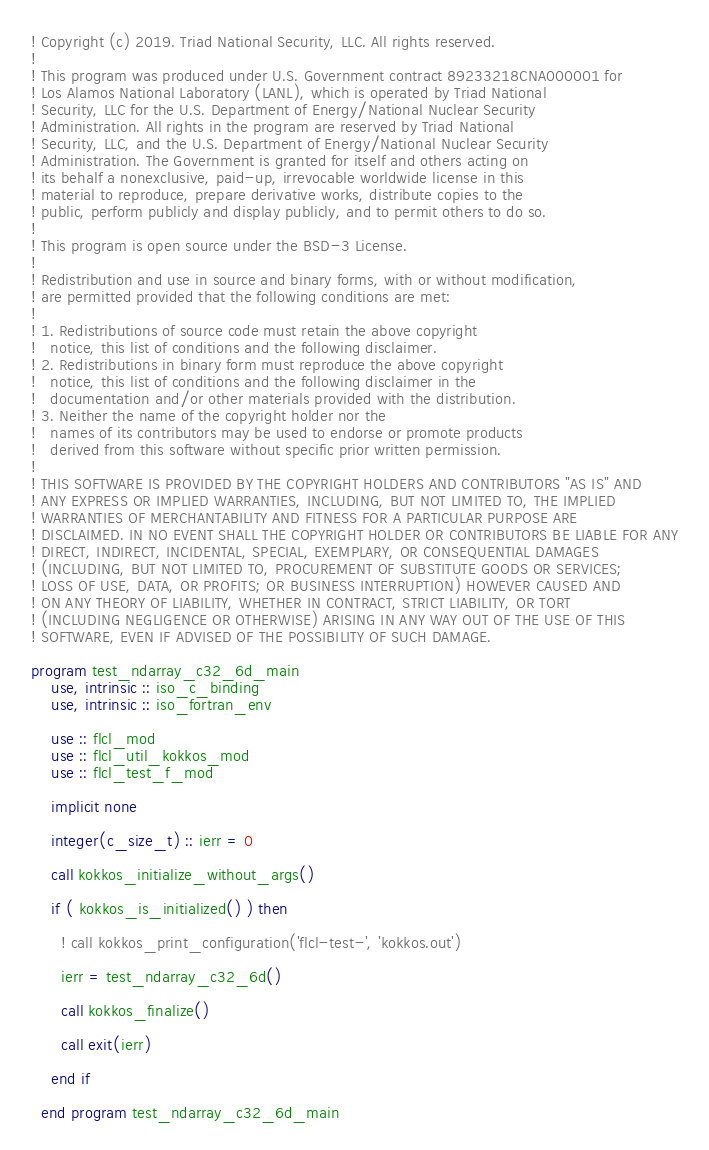Convert code to text. <code><loc_0><loc_0><loc_500><loc_500><_FORTRAN_>! Copyright (c) 2019. Triad National Security, LLC. All rights reserved.
!
! This program was produced under U.S. Government contract 89233218CNA000001 for
! Los Alamos National Laboratory (LANL), which is operated by Triad National
! Security, LLC for the U.S. Department of Energy/National Nuclear Security
! Administration. All rights in the program are reserved by Triad National
! Security, LLC, and the U.S. Department of Energy/National Nuclear Security
! Administration. The Government is granted for itself and others acting on
! its behalf a nonexclusive, paid-up, irrevocable worldwide license in this
! material to reproduce, prepare derivative works, distribute copies to the
! public, perform publicly and display publicly, and to permit others to do so.
!
! This program is open source under the BSD-3 License.
!
! Redistribution and use in source and binary forms, with or without modification,
! are permitted provided that the following conditions are met:
!
! 1. Redistributions of source code must retain the above copyright
!   notice, this list of conditions and the following disclaimer.
! 2. Redistributions in binary form must reproduce the above copyright
!   notice, this list of conditions and the following disclaimer in the
!   documentation and/or other materials provided with the distribution.
! 3. Neither the name of the copyright holder nor the
!   names of its contributors may be used to endorse or promote products
!   derived from this software without specific prior written permission.
!
! THIS SOFTWARE IS PROVIDED BY THE COPYRIGHT HOLDERS AND CONTRIBUTORS "AS IS" AND
! ANY EXPRESS OR IMPLIED WARRANTIES, INCLUDING, BUT NOT LIMITED TO, THE IMPLIED
! WARRANTIES OF MERCHANTABILITY AND FITNESS FOR A PARTICULAR PURPOSE ARE
! DISCLAIMED. IN NO EVENT SHALL THE COPYRIGHT HOLDER OR CONTRIBUTORS BE LIABLE FOR ANY
! DIRECT, INDIRECT, INCIDENTAL, SPECIAL, EXEMPLARY, OR CONSEQUENTIAL DAMAGES
! (INCLUDING, BUT NOT LIMITED TO, PROCUREMENT OF SUBSTITUTE GOODS OR SERVICES;
! LOSS OF USE, DATA, OR PROFITS; OR BUSINESS INTERRUPTION) HOWEVER CAUSED AND
! ON ANY THEORY OF LIABILITY, WHETHER IN CONTRACT, STRICT LIABILITY, OR TORT
! (INCLUDING NEGLIGENCE OR OTHERWISE) ARISING IN ANY WAY OUT OF THE USE OF THIS
! SOFTWARE, EVEN IF ADVISED OF THE POSSIBILITY OF SUCH DAMAGE.

program test_ndarray_c32_6d_main
    use, intrinsic :: iso_c_binding
    use, intrinsic :: iso_fortran_env
  
    use :: flcl_mod
    use :: flcl_util_kokkos_mod
    use :: flcl_test_f_mod
  
    implicit none
  
    integer(c_size_t) :: ierr = 0
  
    call kokkos_initialize_without_args()

    if ( kokkos_is_initialized() ) then
      
      ! call kokkos_print_configuration('flcl-test-', 'kokkos.out')
  
      ierr = test_ndarray_c32_6d()
  
      call kokkos_finalize()
  
      call exit(ierr)

    end if
    
  end program test_ndarray_c32_6d_main</code> 